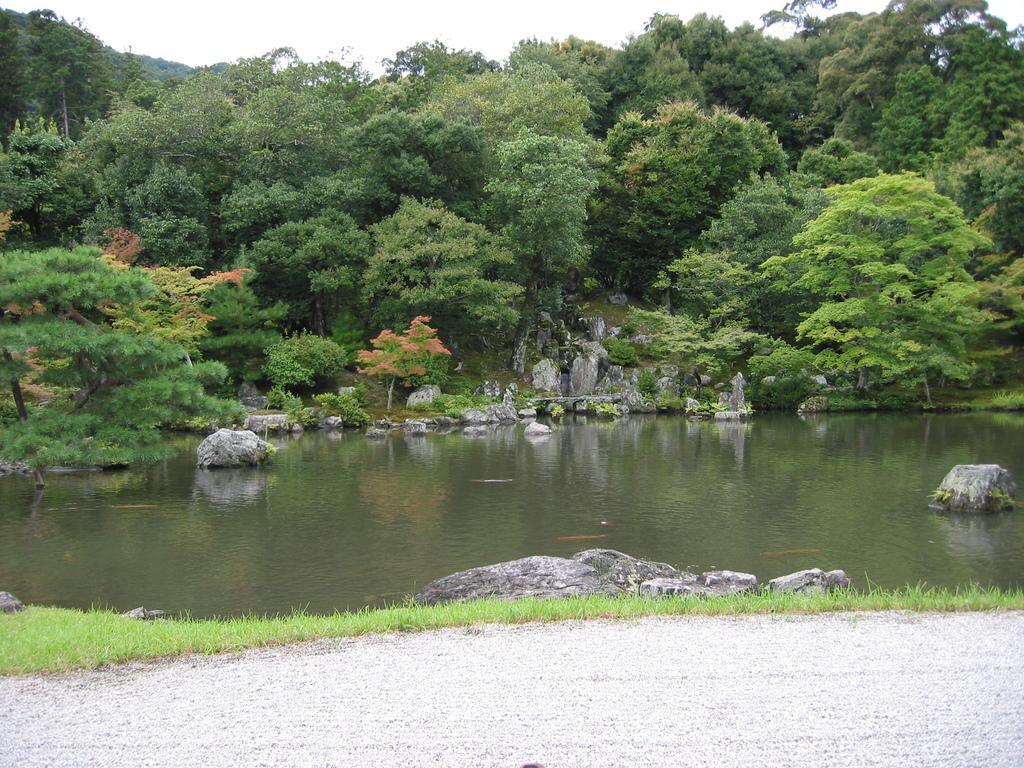Please provide a concise description of this image. In this image we can see water, grass, ground, rocks, plants, and trees. In the background there is sky. 